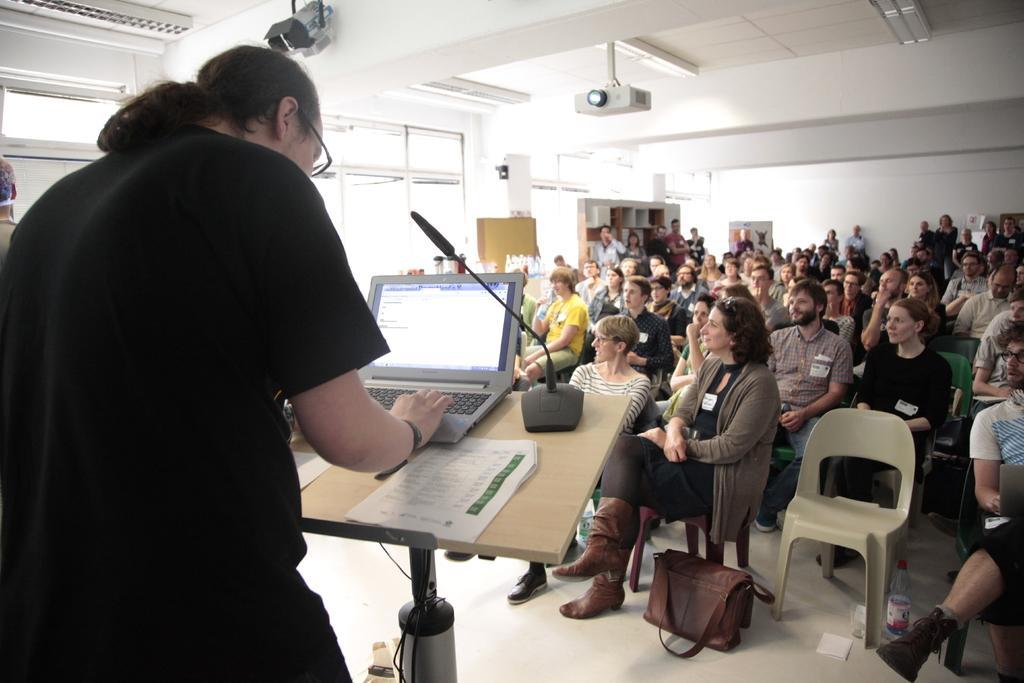How would you summarize this image in a sentence or two? This is a picture where we have a group of people sitting on the chairs in front of them there is a guy in black color who is standing in front of a desk where there is a mike and there is a projector in the room. 